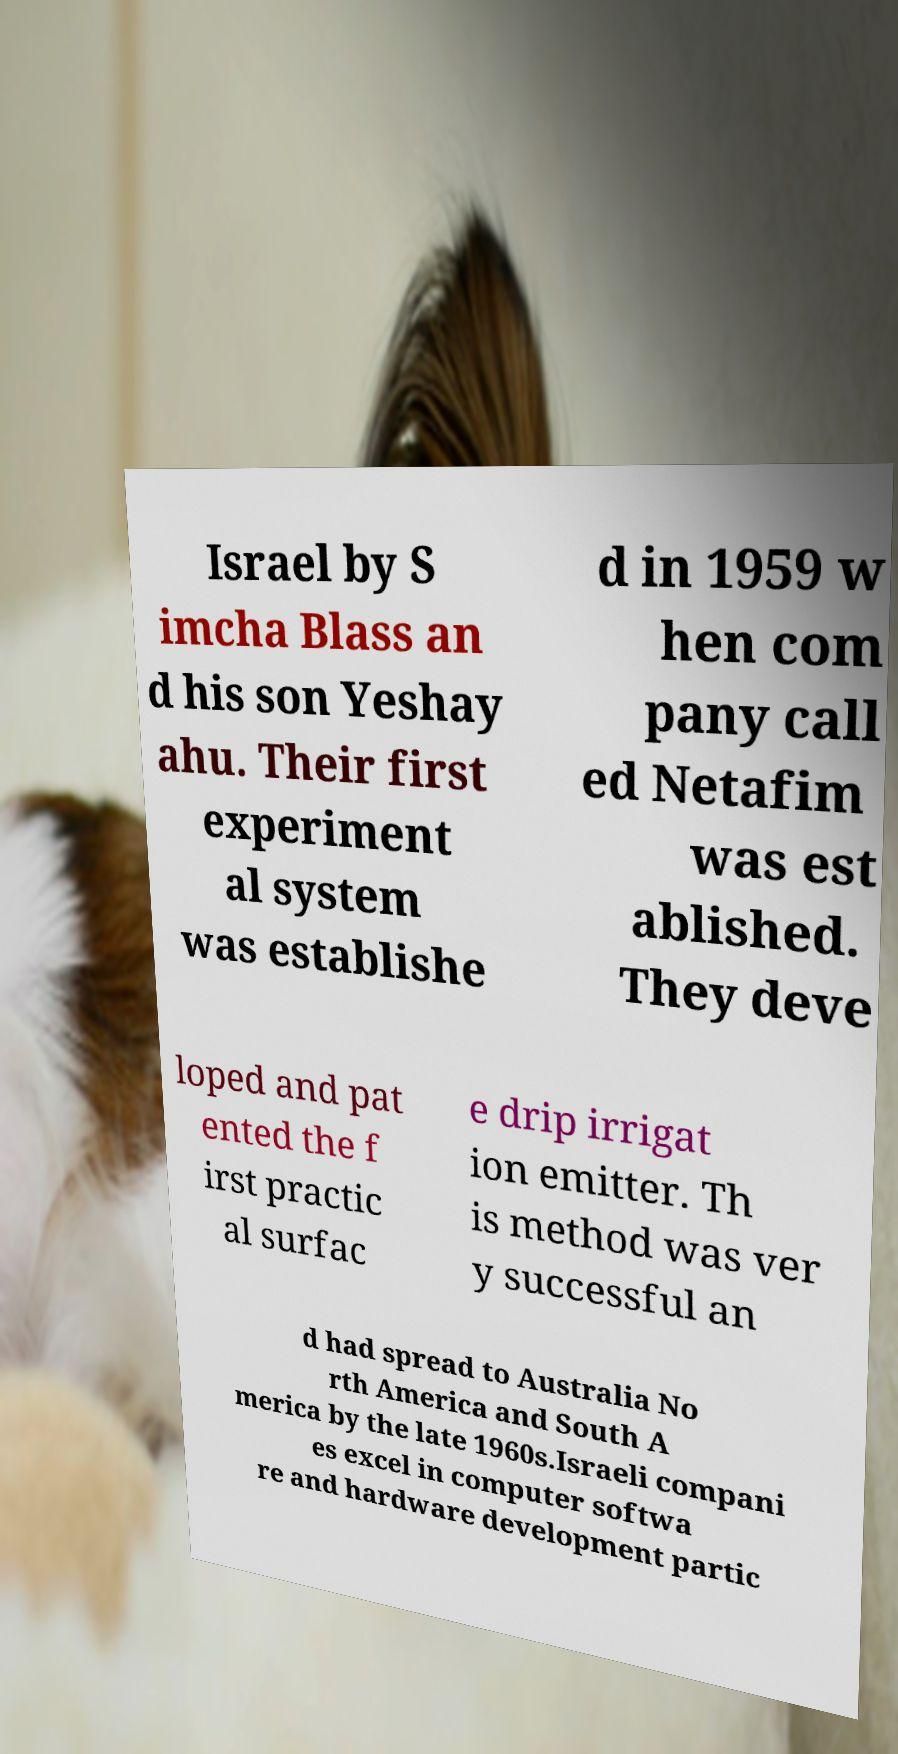I need the written content from this picture converted into text. Can you do that? Israel by S imcha Blass an d his son Yeshay ahu. Their first experiment al system was establishe d in 1959 w hen com pany call ed Netafim was est ablished. They deve loped and pat ented the f irst practic al surfac e drip irrigat ion emitter. Th is method was ver y successful an d had spread to Australia No rth America and South A merica by the late 1960s.Israeli compani es excel in computer softwa re and hardware development partic 